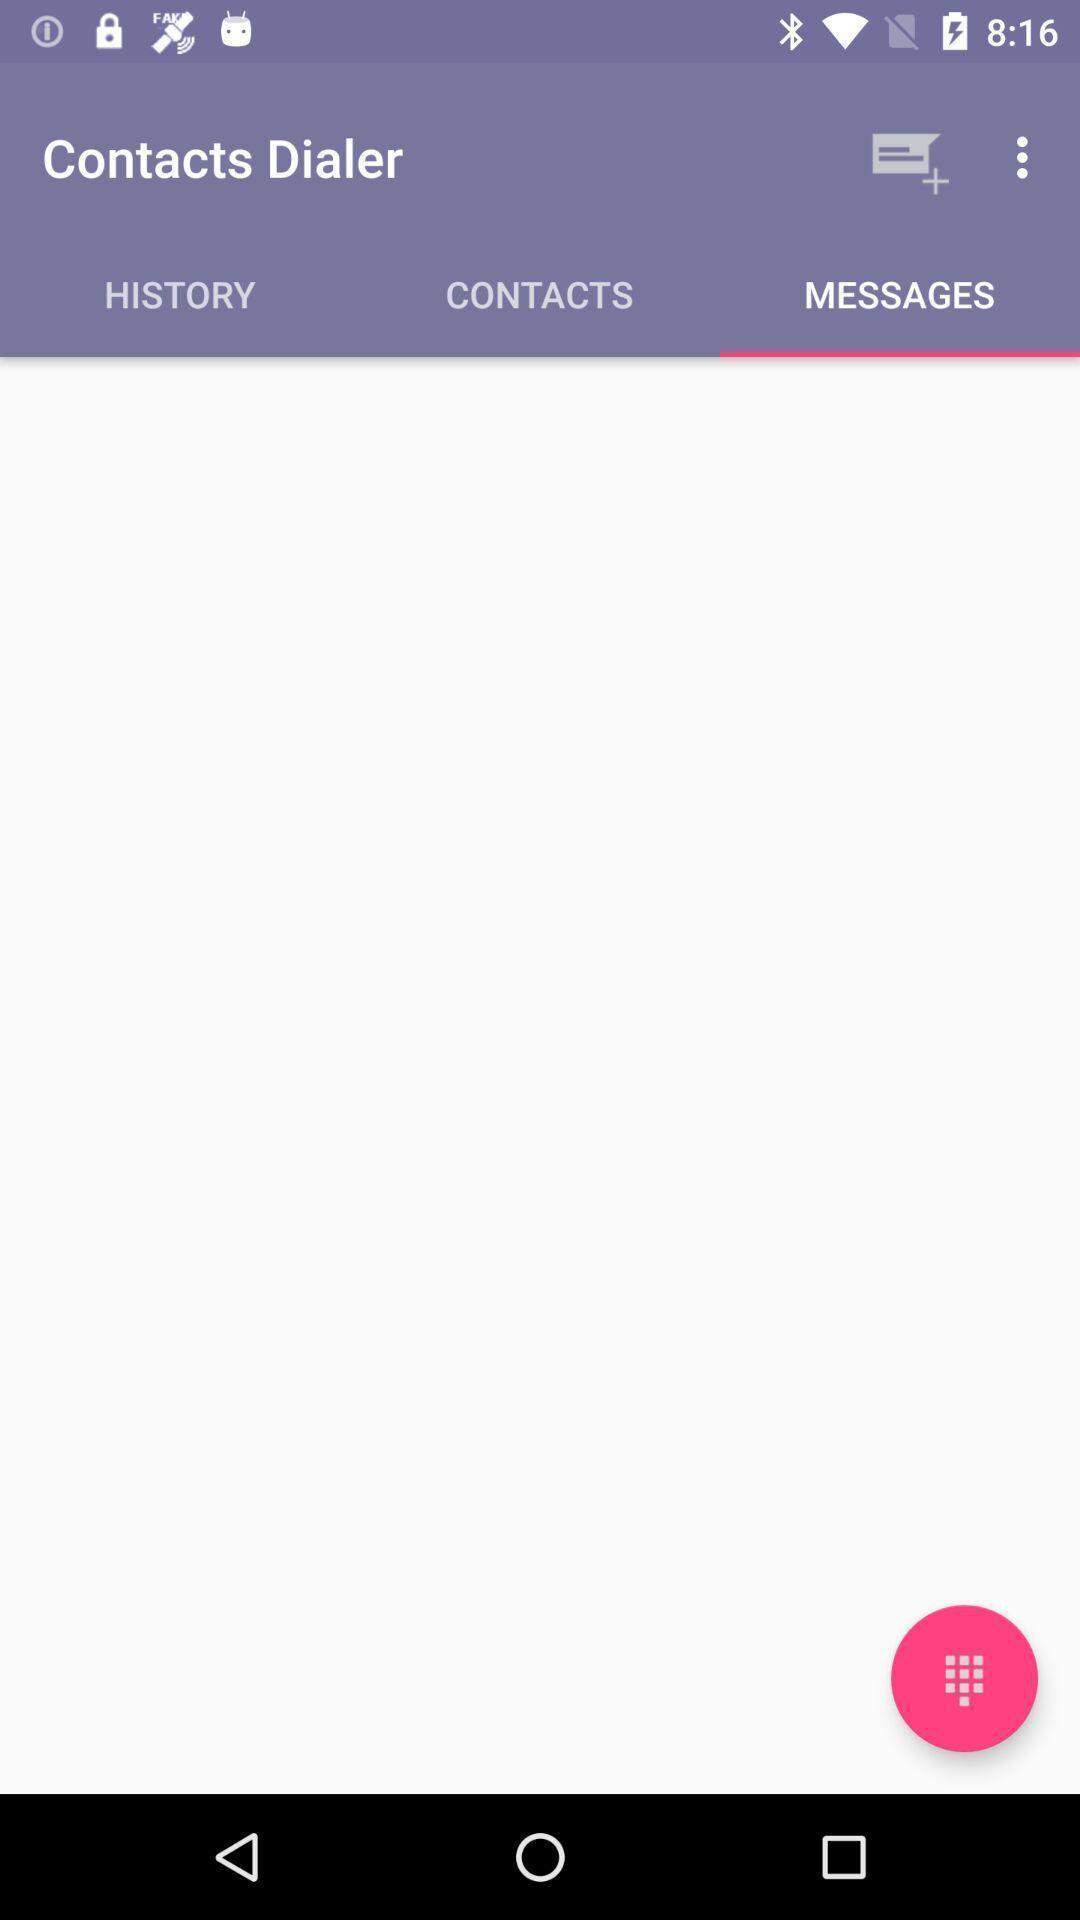What is the overall content of this screenshot? Screen showing messages. 